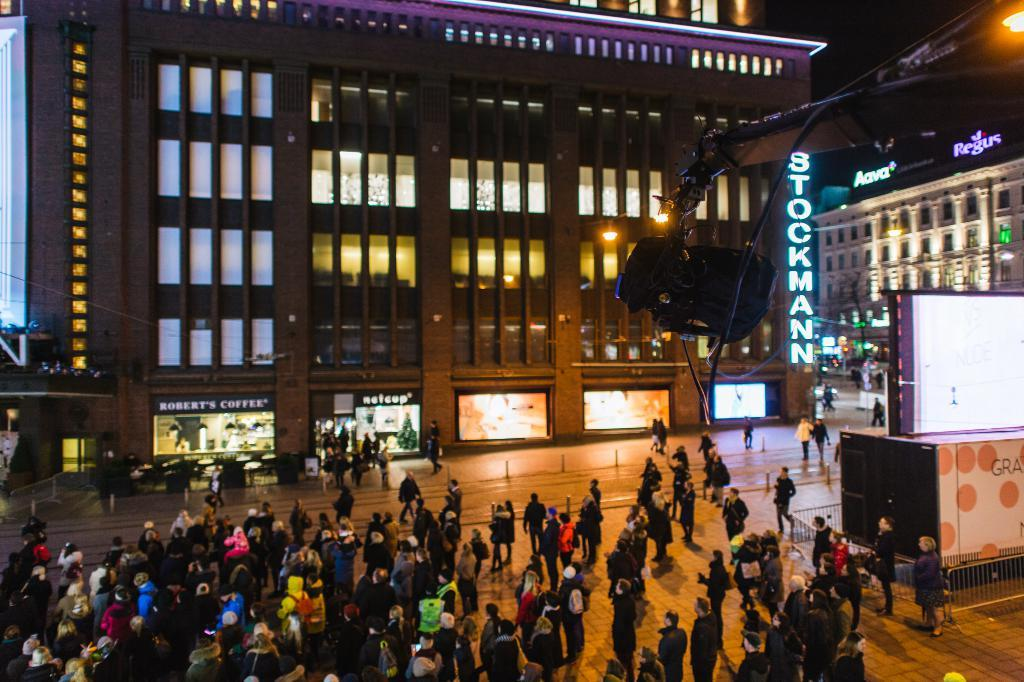Provide a one-sentence caption for the provided image. A building with the name Stockmann, with shops for Robert's coffee and Netcup at street level. 